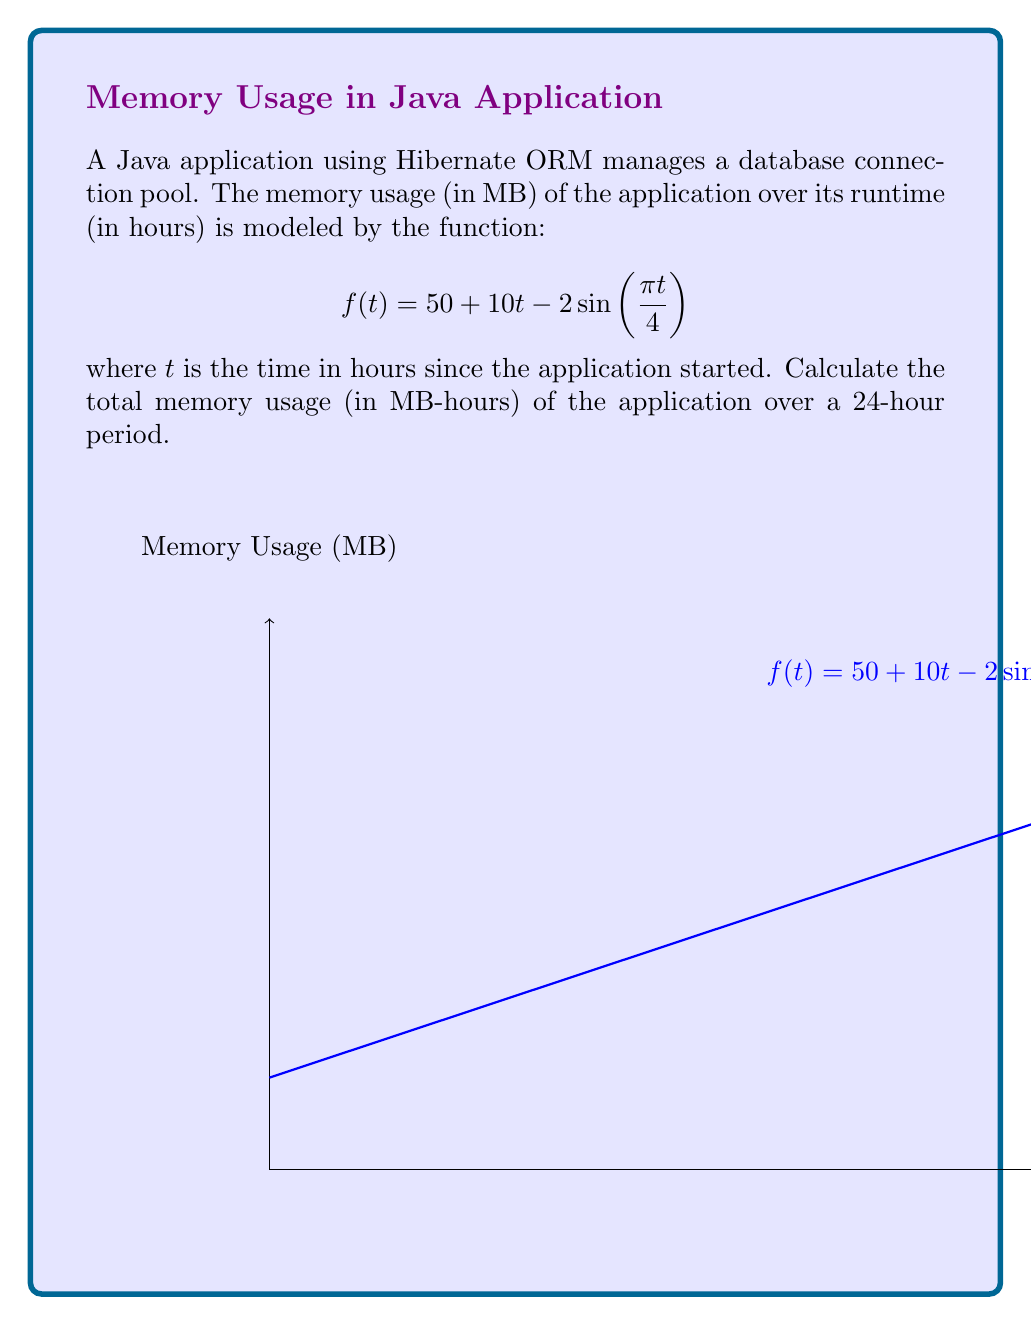Teach me how to tackle this problem. To calculate the total memory usage over 24 hours, we need to evaluate the definite integral of the given function from $t=0$ to $t=24$. Let's break this down step-by-step:

1) The integral we need to evaluate is:

   $$\int_0^{24} (50 + 10t - 2\sin(\frac{\pi t}{4})) dt$$

2) Let's integrate each term separately:

   a) $\int 50 dt = 50t$
   
   b) $\int 10t dt = 5t^2$
   
   c) $\int -2\sin(\frac{\pi t}{4}) dt = \frac{8}{\pi} \cos(\frac{\pi t}{4})$

3) Now, let's apply the fundamental theorem of calculus:

   $$\left[50t + 5t^2 + \frac{8}{\pi} \cos(\frac{\pi t}{4})\right]_0^{24}$$

4) Evaluate at $t=24$ and $t=0$:

   At $t=24$: $50(24) + 5(24^2) + \frac{8}{\pi} \cos(6\pi) = 1200 + 2880 + \frac{8}{\pi}$
   
   At $t=0$: $50(0) + 5(0^2) + \frac{8}{\pi} \cos(0) = 0 + 0 + \frac{8}{\pi}$

5) Subtract the values:

   $$(1200 + 2880 + \frac{8}{\pi}) - (0 + 0 + \frac{8}{\pi}) = 4080$$

Therefore, the total memory usage over 24 hours is 4080 MB-hours.
Answer: 4080 MB-hours 